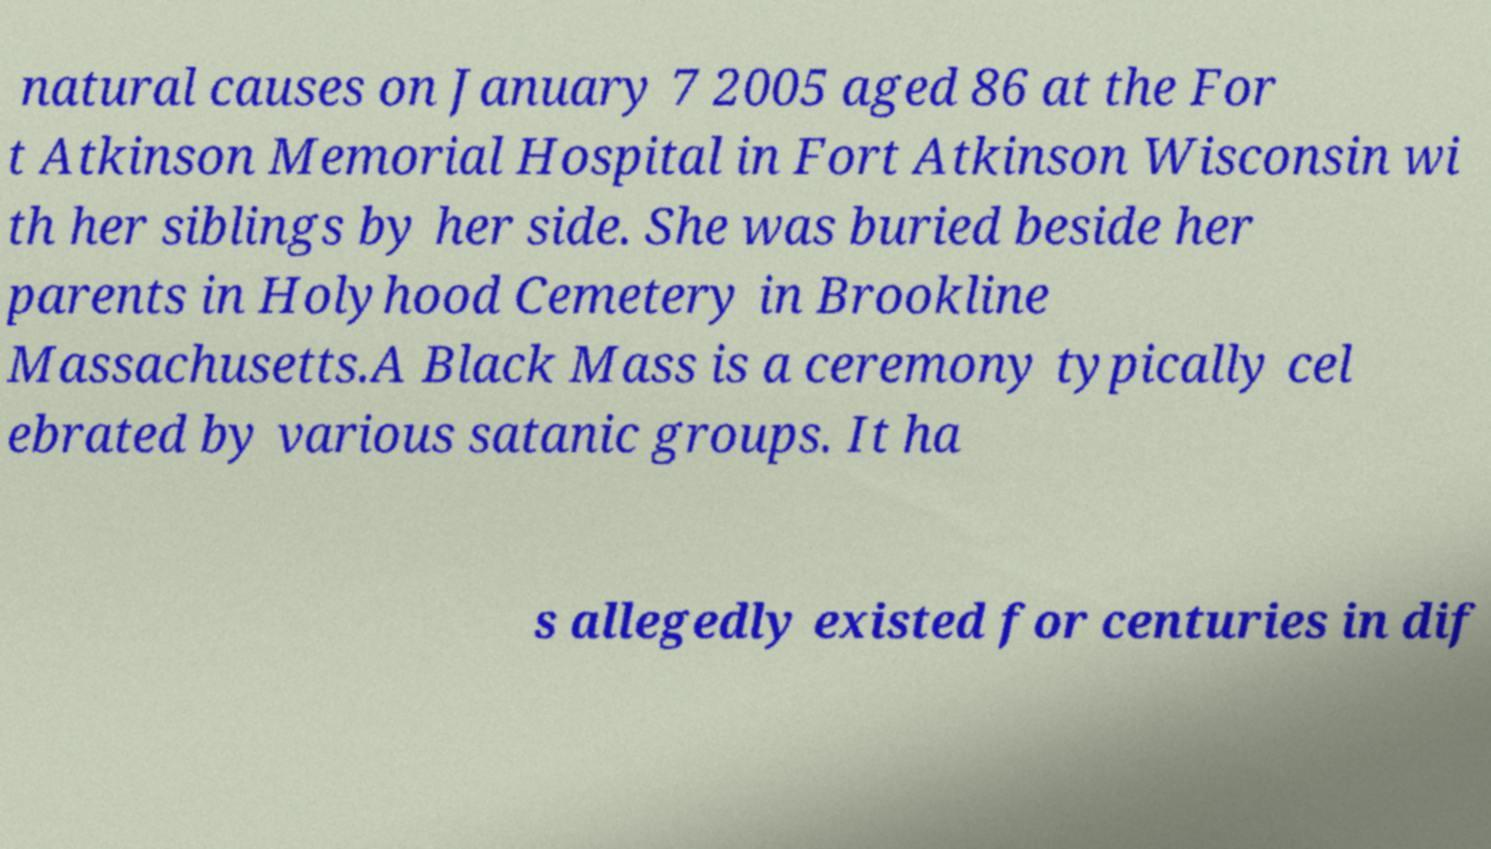Could you assist in decoding the text presented in this image and type it out clearly? natural causes on January 7 2005 aged 86 at the For t Atkinson Memorial Hospital in Fort Atkinson Wisconsin wi th her siblings by her side. She was buried beside her parents in Holyhood Cemetery in Brookline Massachusetts.A Black Mass is a ceremony typically cel ebrated by various satanic groups. It ha s allegedly existed for centuries in dif 